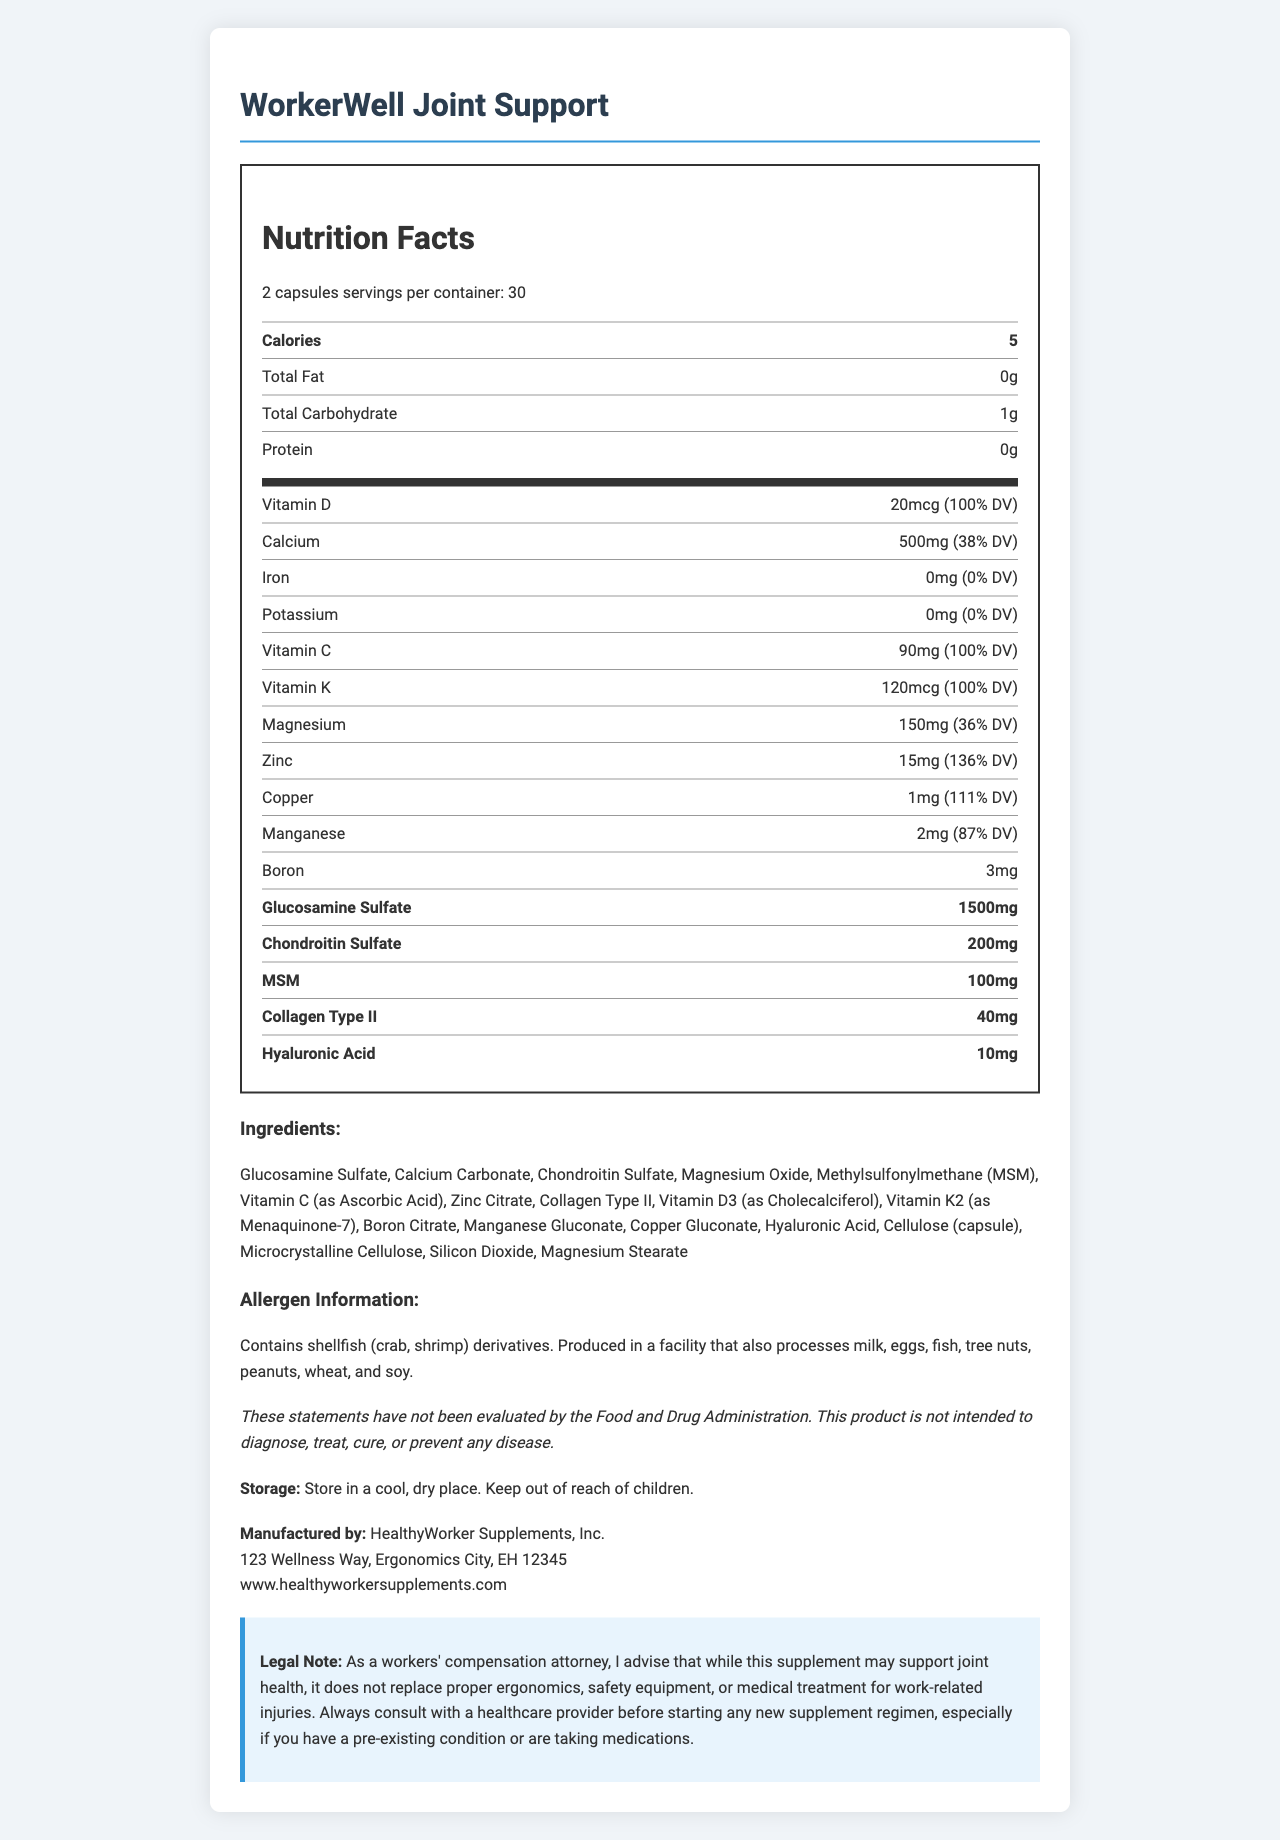what is the serving size? The serving size is indicated in the nutrition facts section of the document as "2 capsules".
Answer: 2 capsules how many servings are there per container? The number of servings per container is stated as "30" in the nutrition facts section.
Answer: 30 how many calories are in one serving? The calories per serving are listed as "5" in the nutrition facts section.
Answer: 5 what is the daily value percentage of Vitamin D? The Vitamin D content is shown as "20mcg (100% DV)" in the nutrition facts section.
Answer: 100% DV which vitamin has the highest daily value percentage? Both Vitamin D and Vitamin C are listed with a daily value percentage of 100% in the nutrition facts section.
Answer: Vitamin D and Vitamin C how much calcium is in one serving? The calcium content is mentioned as "500mg (38% DV)" in the nutrition facts section.
Answer: 500mg what ingredients are included in the supplement? The full list of ingredients is provided under the ingredients section of the document.
Answer: Glucosamine Sulfate, Calcium Carbonate, Chondroitin Sulfate, Magnesium Oxide, Methylsulfonylmethane (MSM), Vitamin C (as Ascorbic Acid), Zinc Citrate, Collagen Type II, Vitamin D3 (as Cholecalciferol), Vitamin K2 (as Menaquinone-7), Boron Citrate, Manganese Gluconate, Copper Gluconate, Hyaluronic Acid, Cellulose (capsule), Microcrystalline Cellulose, Silicon Dioxide, Magnesium Stearate which of these minerals is not present in this supplement? A. Iron B. Zinc C. Magnesium D. Potassium According to the nutrition facts, Iron, Zinc, and Magnesium are present in the supplement, but Potassium is not.
Answer: D. Potassium what is the main purpose of this dietary supplement? A. Support joint health B. Improve vision C. Enhance memory D. Boost energy The document's context and the specialized formulation of key minerals and vitamins are targeted towards supporting bone and joint health.
Answer: A. Support joint health does this supplement contain any allergens? The allergen information section indicates that it contains shellfish (crab, shrimp) derivatives.
Answer: Yes can the product be used as a replacement for medical treatment for work-related injuries? The legal note clarifies that this supplement does not replace proper medical treatment for work-related injuries.
Answer: No describe the main idea of the document The entire document provides a comprehensive overview of a dietary supplement aimed at aiding workers with bone and joint health through detailed nutrition information, ingredients, warnings, and manufacturer data.
Answer: The document describes the nutrition facts, ingredients, allergen information, and other relevant details for WorkerWell Joint Support, a dietary supplement formulated to support bone and joint health in workers prone to repetitive strain injuries. It highlights key minerals and vitamins included in the supplement, serving size, and daily value percentages, along with storage information, manufacturer's details, and a legal disclaimer. what is the exact amount of MSM in one serving? The nutrition facts list MSM as "100mg" per serving.
Answer: 100mg which vitamin is present at a 100% daily value and is known for promoting bone health? Vitamin D is listed with a daily value of 100%, and it is well-known for its role in maintaining bone health.
Answer: Vitamin D how much collagen type ii is included in each serving? The amount of Collagen Type II per serving is specified as "40mg" in the nutrition facts section.
Answer: 40mg where is the manufacturer located? The manufacturer's address is provided under the manufacturer section of the document.
Answer: 123 Wellness Way, Ergonomics City, EH 12345 who should workers consult before starting this supplement? The legal note advises consulting a healthcare provider before starting any new supplement regimen.
Answer: Healthcare provider to what extent does boron contribute to the daily value percentage? The document does not provide a daily value percentage for Boron.
Answer: Not specified 